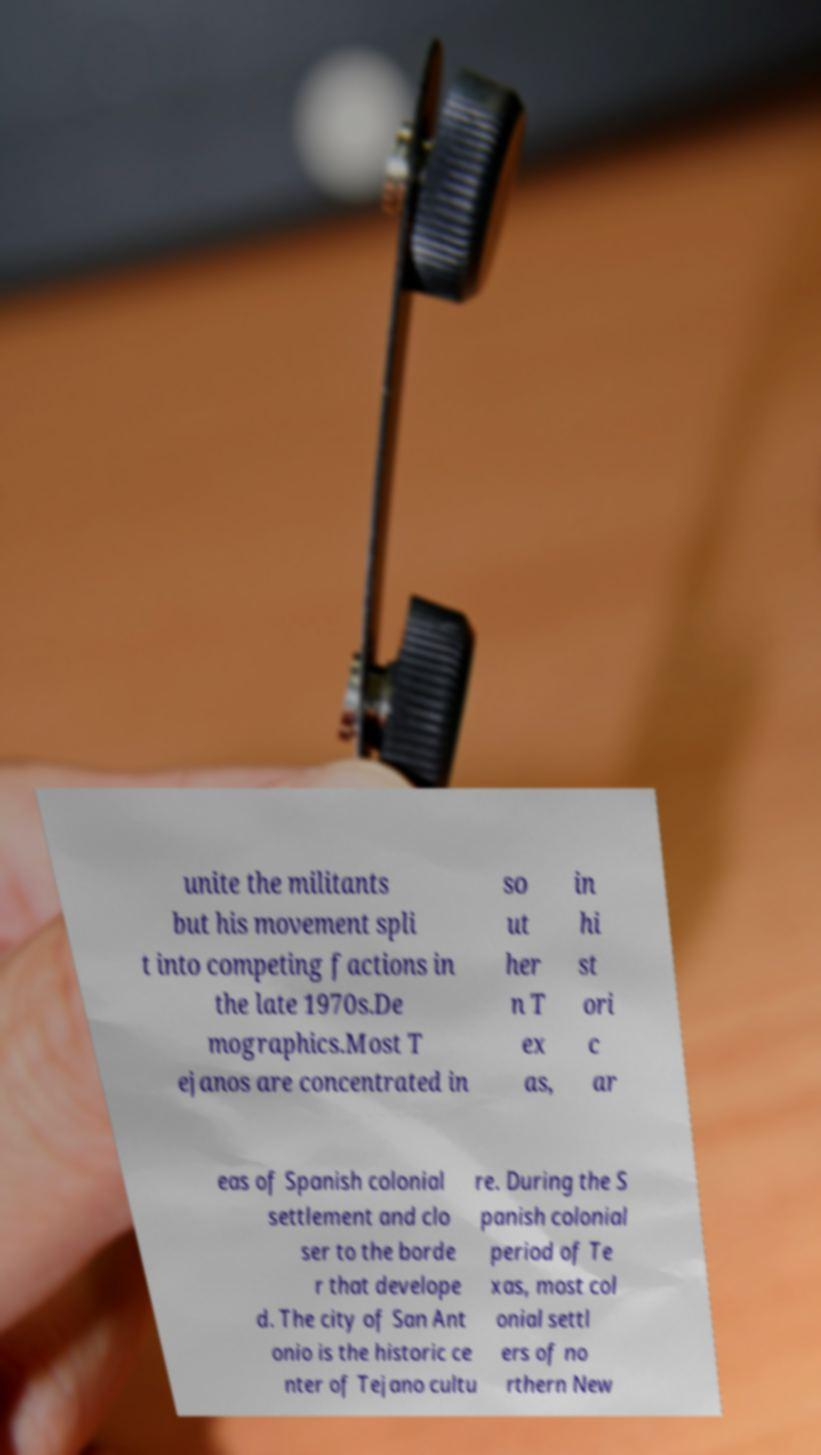Could you extract and type out the text from this image? unite the militants but his movement spli t into competing factions in the late 1970s.De mographics.Most T ejanos are concentrated in so ut her n T ex as, in hi st ori c ar eas of Spanish colonial settlement and clo ser to the borde r that develope d. The city of San Ant onio is the historic ce nter of Tejano cultu re. During the S panish colonial period of Te xas, most col onial settl ers of no rthern New 